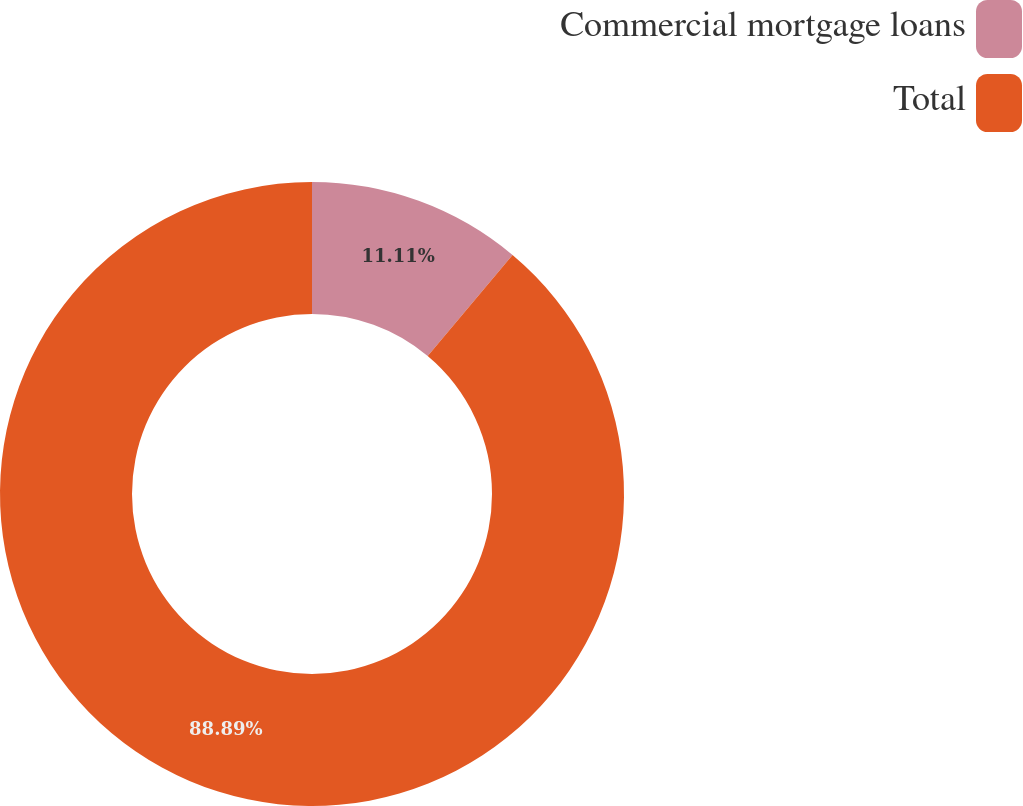Convert chart. <chart><loc_0><loc_0><loc_500><loc_500><pie_chart><fcel>Commercial mortgage loans<fcel>Total<nl><fcel>11.11%<fcel>88.89%<nl></chart> 